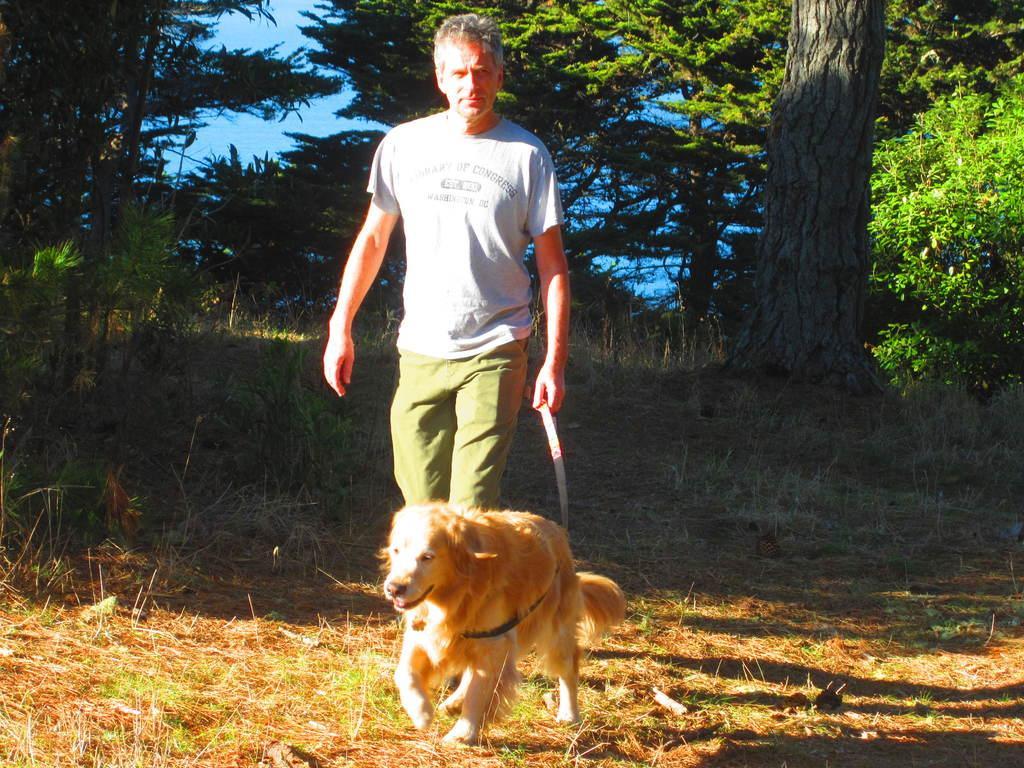How would you summarize this image in a sentence or two? A man is walking along with the dog. He is catching the belt of the dog. At the back side there are trees. At the bottom there is a grass on the ground. 